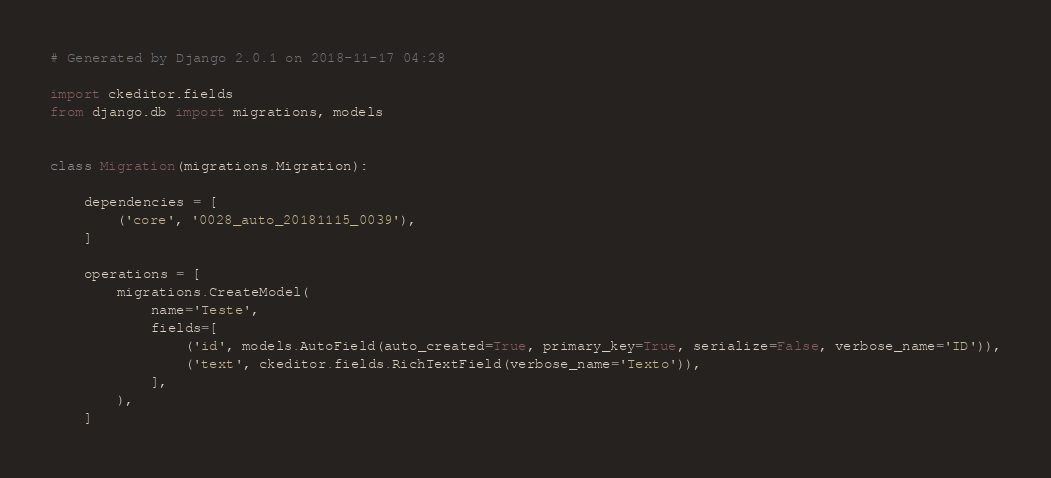Convert code to text. <code><loc_0><loc_0><loc_500><loc_500><_Python_># Generated by Django 2.0.1 on 2018-11-17 04:28

import ckeditor.fields
from django.db import migrations, models


class Migration(migrations.Migration):

    dependencies = [
        ('core', '0028_auto_20181115_0039'),
    ]

    operations = [
        migrations.CreateModel(
            name='Teste',
            fields=[
                ('id', models.AutoField(auto_created=True, primary_key=True, serialize=False, verbose_name='ID')),
                ('text', ckeditor.fields.RichTextField(verbose_name='Texto')),
            ],
        ),
    ]
</code> 